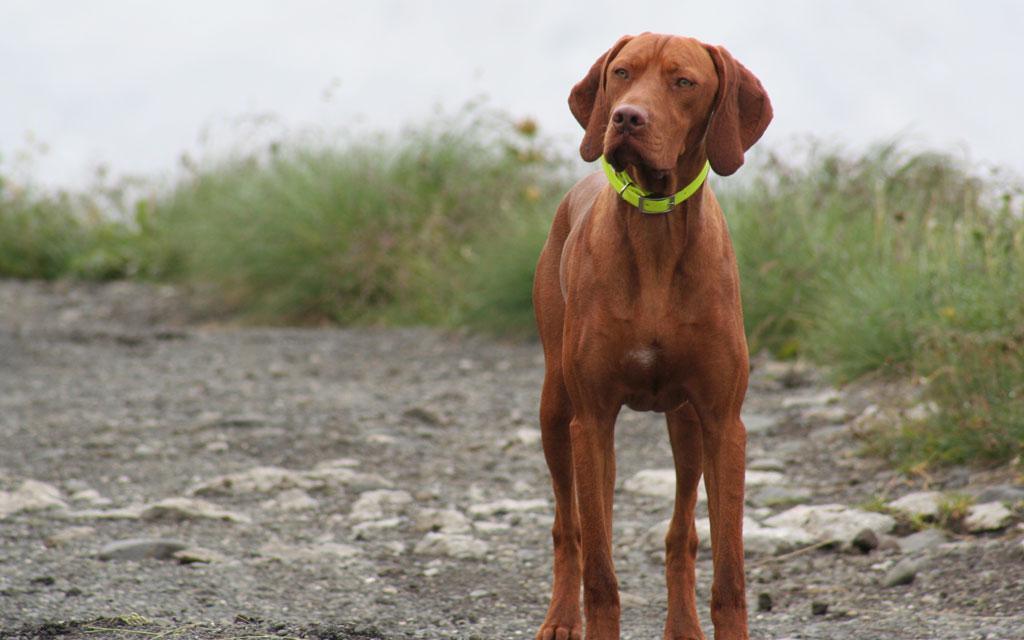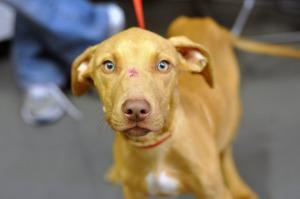The first image is the image on the left, the second image is the image on the right. Considering the images on both sides, is "One image shows a dark red-orange dog standing and wearing a lime green collar, and the other image features a more tan dog with something around its neck." valid? Answer yes or no. Yes. 